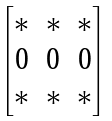<formula> <loc_0><loc_0><loc_500><loc_500>\begin{bmatrix} * & * & * \\ 0 & 0 & 0 \\ * & * & * \end{bmatrix}</formula> 